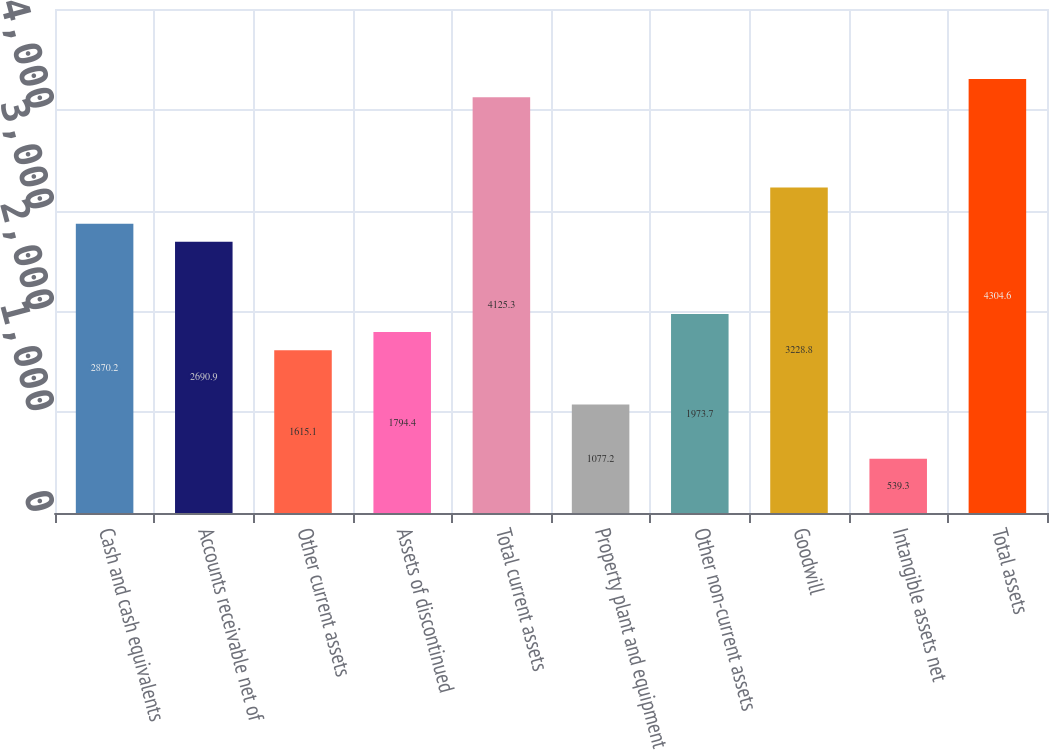Convert chart to OTSL. <chart><loc_0><loc_0><loc_500><loc_500><bar_chart><fcel>Cash and cash equivalents<fcel>Accounts receivable net of<fcel>Other current assets<fcel>Assets of discontinued<fcel>Total current assets<fcel>Property plant and equipment<fcel>Other non-current assets<fcel>Goodwill<fcel>Intangible assets net<fcel>Total assets<nl><fcel>2870.2<fcel>2690.9<fcel>1615.1<fcel>1794.4<fcel>4125.3<fcel>1077.2<fcel>1973.7<fcel>3228.8<fcel>539.3<fcel>4304.6<nl></chart> 